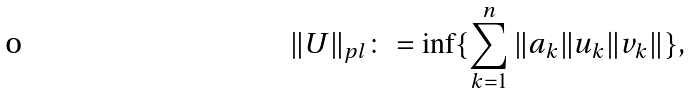<formula> <loc_0><loc_0><loc_500><loc_500>\| U \| _ { p l } \colon = \inf \{ \sum _ { k = 1 } ^ { n } \| a _ { k } \| u _ { k } \| v _ { k } \| \} ,</formula> 